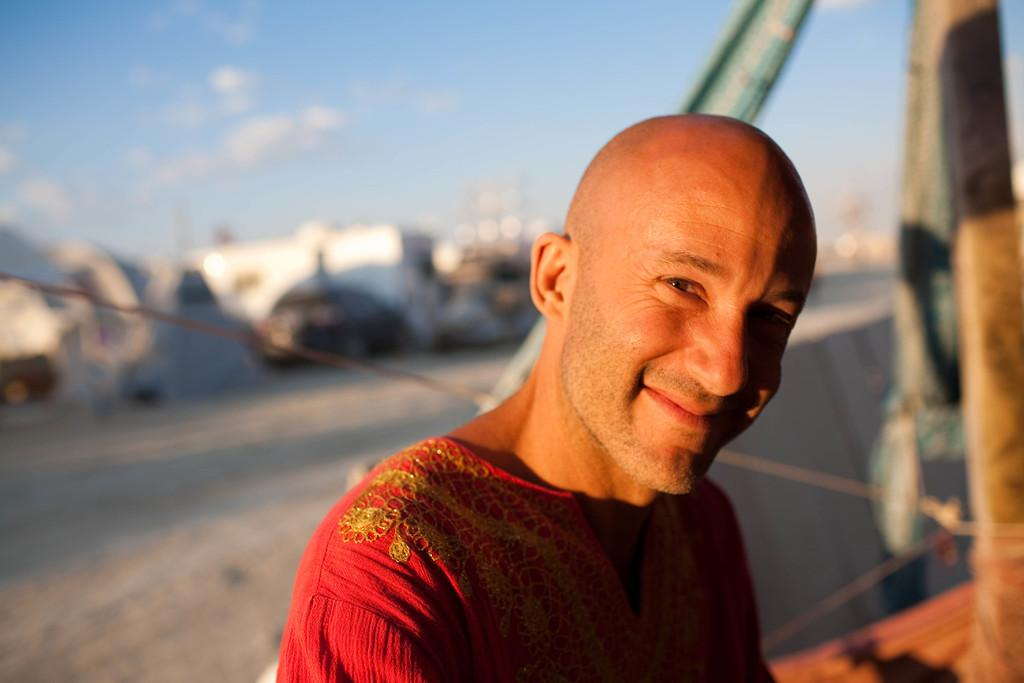What is the main subject in the foreground of the image? There is a person in the foreground of the image. What can be seen in the right corner of the image? There is an object in the right corner of the image. What is located in the background of the image? There is a vehicle in the background of the image. What is visible at the top of the image? The sky is visible at the top of the image. What type of glove is the person wearing in the image? There is no glove visible in the image; the person is not wearing any gloves. Can you tell me how many donkeys are present in the image? There are no donkeys present in the image. 